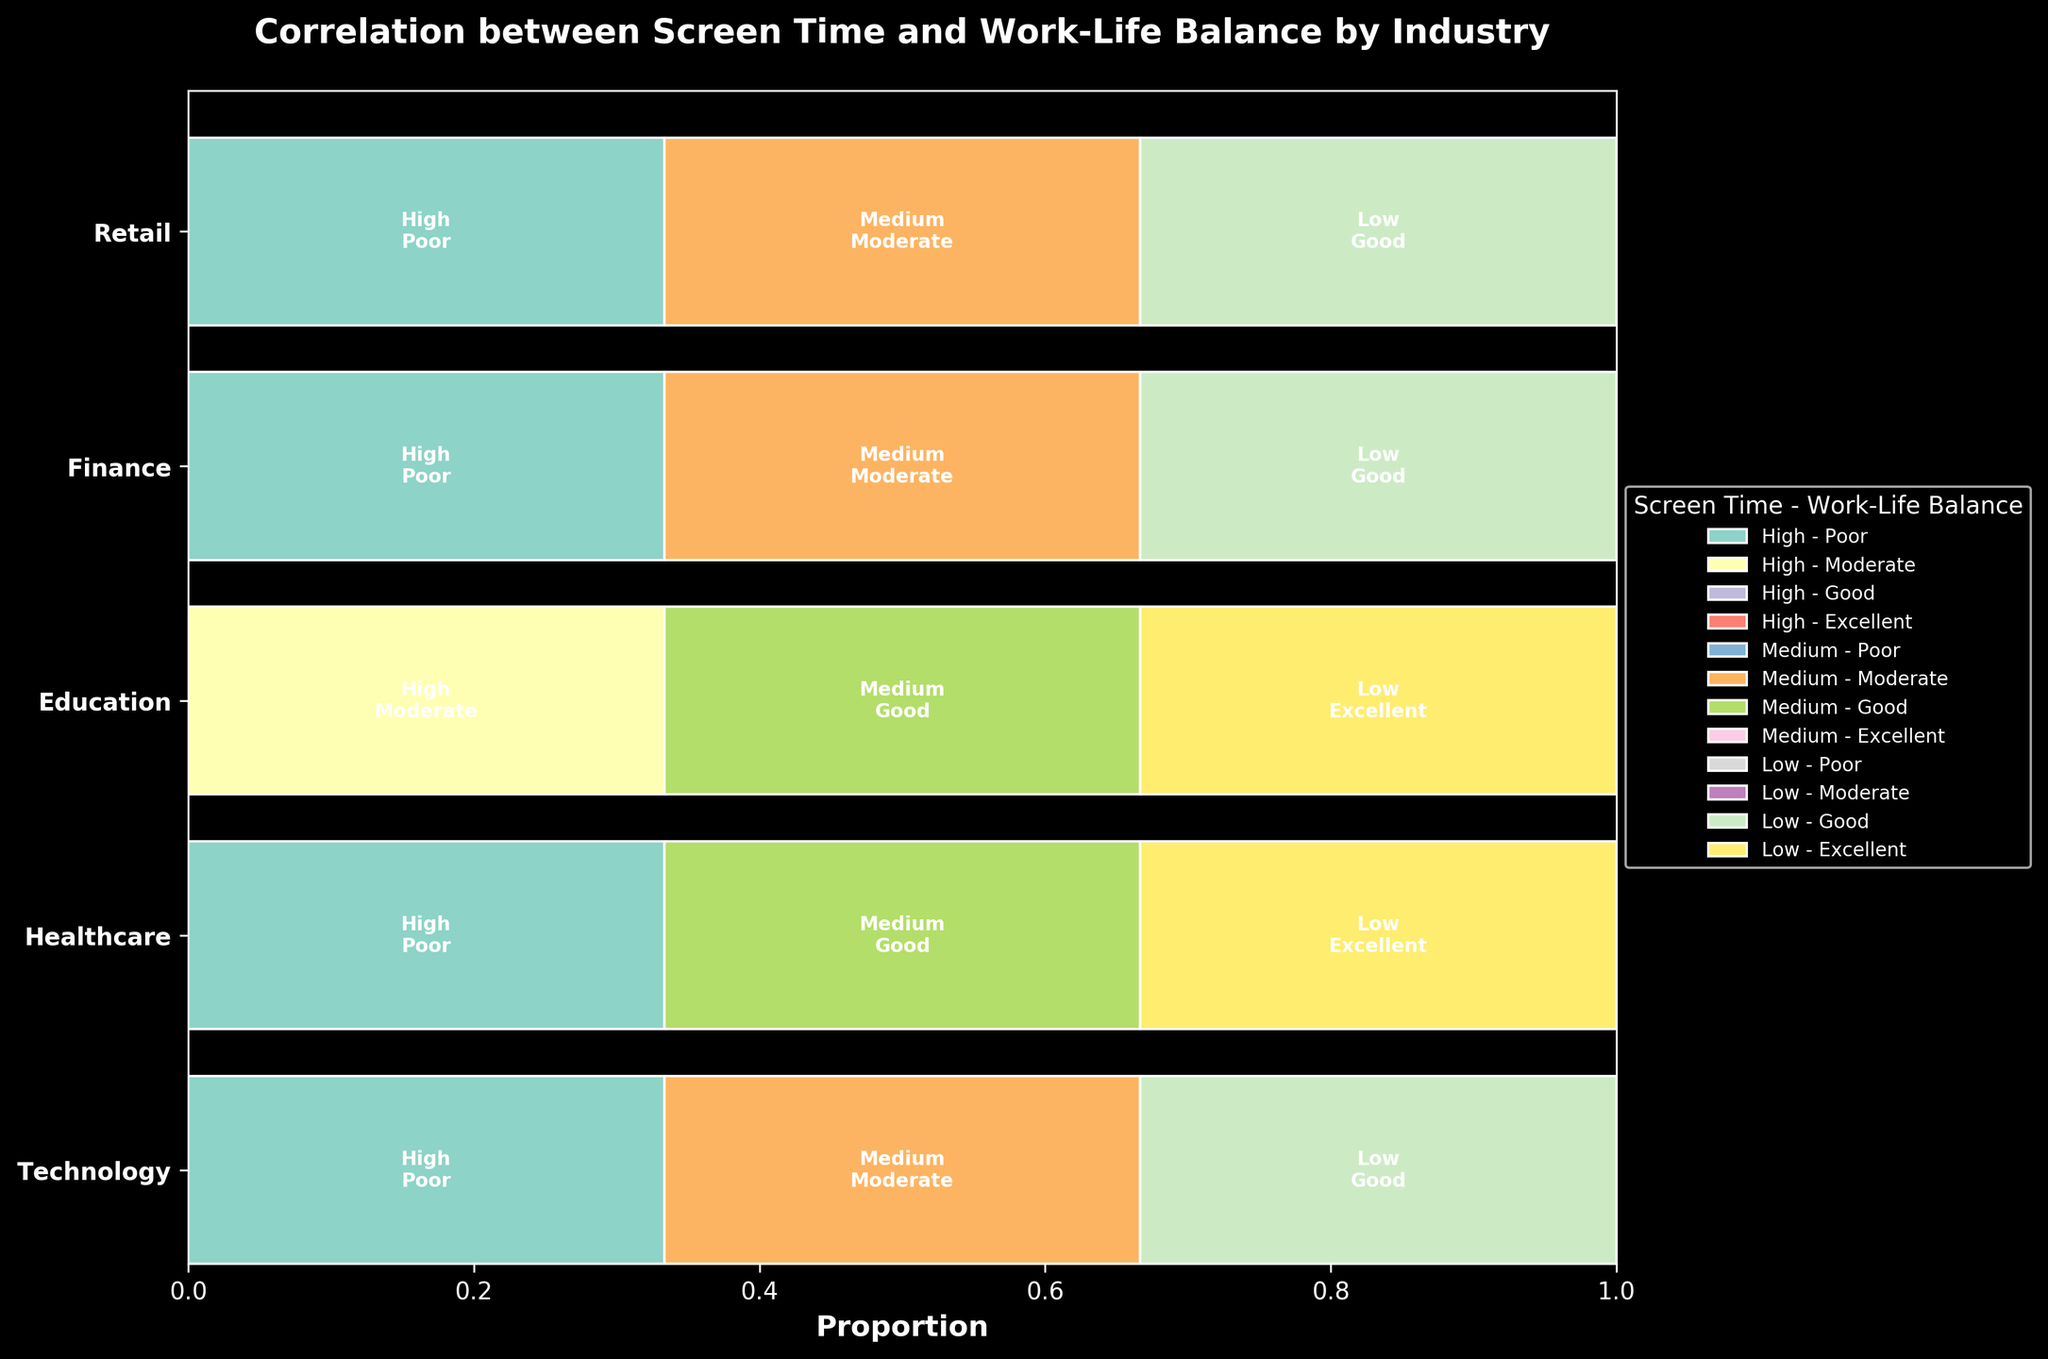What is the title of the plot? The title of the plot is generally found at the top of the figure and is a brief description of what the plot represents. Here, the title is clearly stated.
Answer: Correlation between Screen Time and Work-Life Balance by Industry Which industry has the highest proportion of 'Low' screen time and 'Excellent' work-life balance? To find this, look for the industry with the largest segment of 'Low' screen time that corresponds to 'Excellent' work-life balance. Check the colors and corresponding text inside the segments for accurate identification.
Answer: Education How many industries have a 'High' screen time associated with 'Poor' work-life balance? Count the number of industries that have any proportion of 'High' screen time linked to 'Poor' work-life balance. Identify these by the relevant color and the corresponding text inside the segments.
Answer: 4 What is the dominant work-life balance level for the 'Low' screen time category in the Retail industry? Observe the 'Low' screen time category specifically within the Retail industry and identify which work-life balance level occupies the largest proportion.
Answer: Good Compare the proportion of 'Medium' screen time with 'Moderate' work-life balance between Technology and Finance industries. Which one is greater? For each industry, locate the segment representing 'Medium' screen time with 'Moderate' work-life balance. Compare the widths of these segments to determine which one is greater.
Answer: Technology Which category of screen time is most frequently associated with 'Moderate' work-life balance across different industries? Look across all industries and identify which screen time category ('High', 'Medium', or 'Low') most often corresponds to 'Moderate' work-life balance by observing the proportional size of the relevant segments.
Answer: High Are there any industries where all screen time categories ('High', 'Medium', 'Low') correspond to different work-life balance levels? For each industry, check if the 'High', 'Medium', and 'Low' screen time categories correspond to distinct work-life balance levels without any repetition.
Answer: Education 